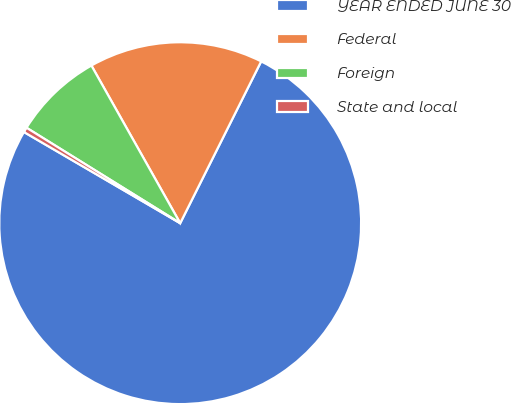Convert chart. <chart><loc_0><loc_0><loc_500><loc_500><pie_chart><fcel>YEAR ENDED JUNE 30<fcel>Federal<fcel>Foreign<fcel>State and local<nl><fcel>76.02%<fcel>15.55%<fcel>7.99%<fcel>0.44%<nl></chart> 